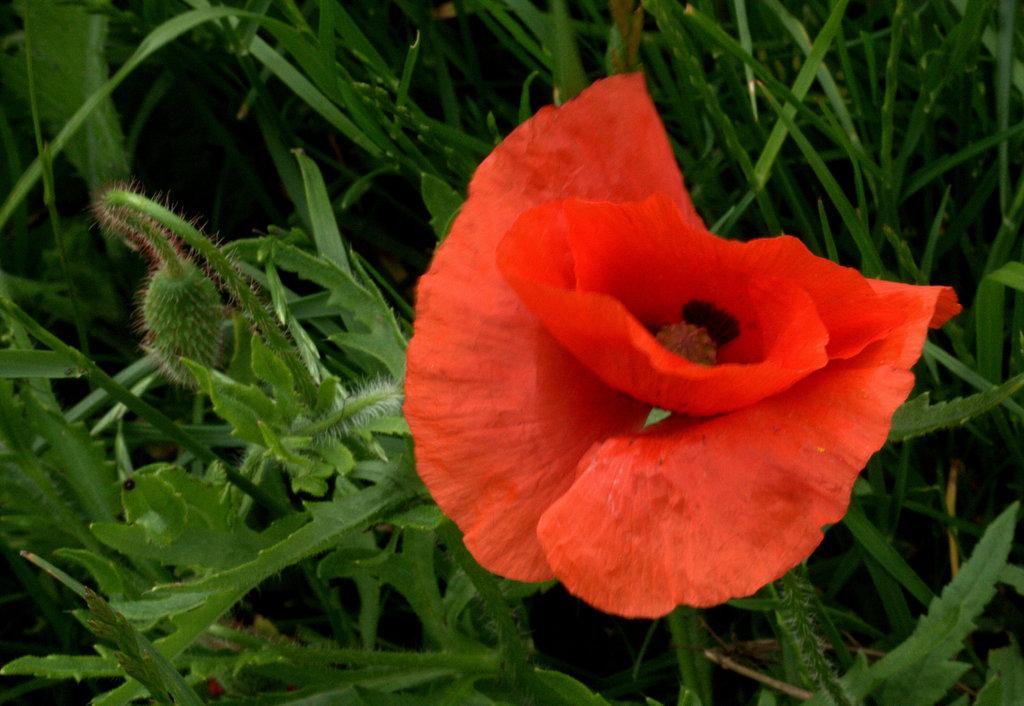What is the main subject of the image? There is a flower in the image. Are there any other plants visible in the image? Yes, there are plants behind the flower in the image. What type of soap is being used to water the plants in the image? There is no soap present in the image, and the plants are not being watered. 